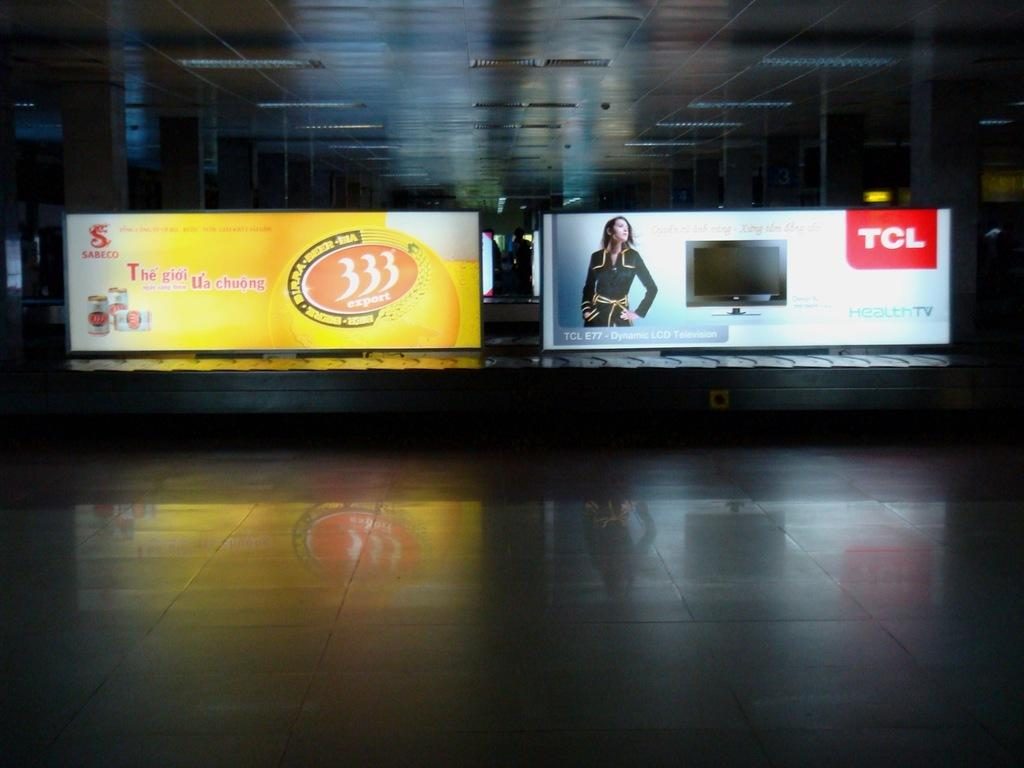<image>
Create a compact narrative representing the image presented. Sabesco and TCL photos that are pictured on a screen. 